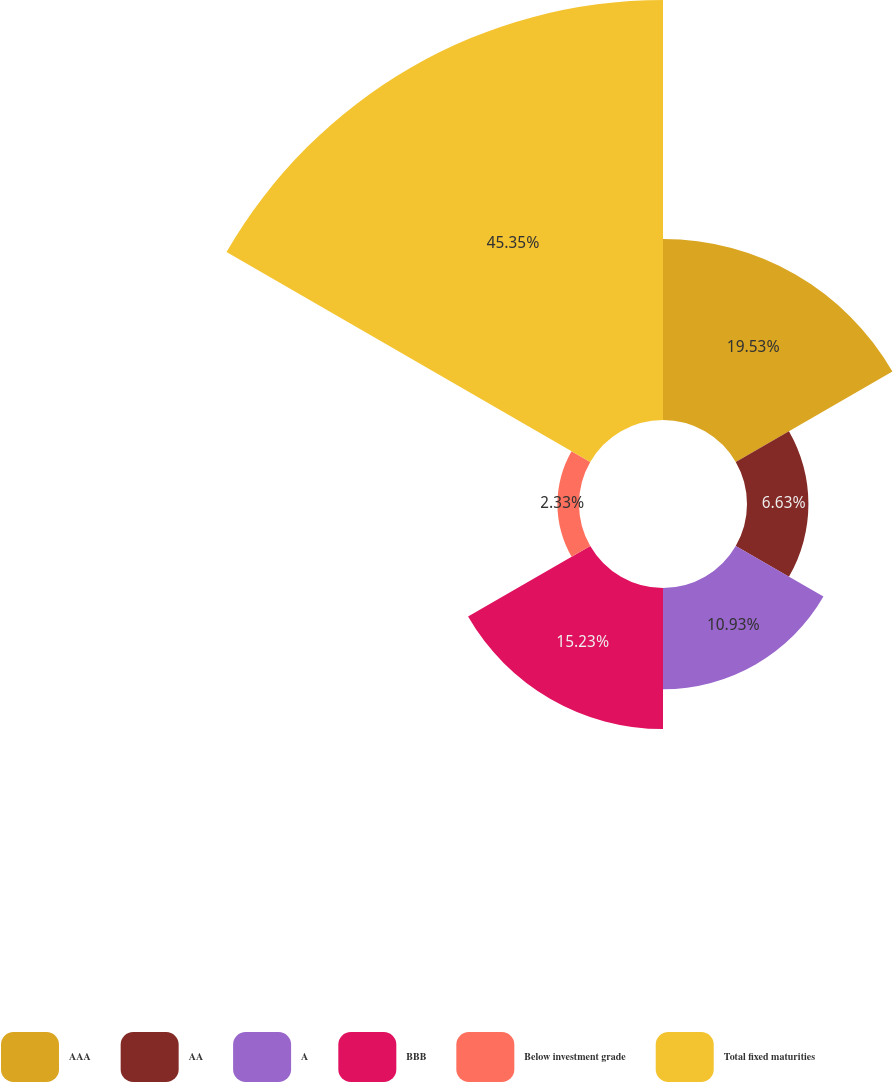Convert chart. <chart><loc_0><loc_0><loc_500><loc_500><pie_chart><fcel>AAA<fcel>AA<fcel>A<fcel>BBB<fcel>Below investment grade<fcel>Total fixed maturities<nl><fcel>19.53%<fcel>6.63%<fcel>10.93%<fcel>15.23%<fcel>2.33%<fcel>45.34%<nl></chart> 